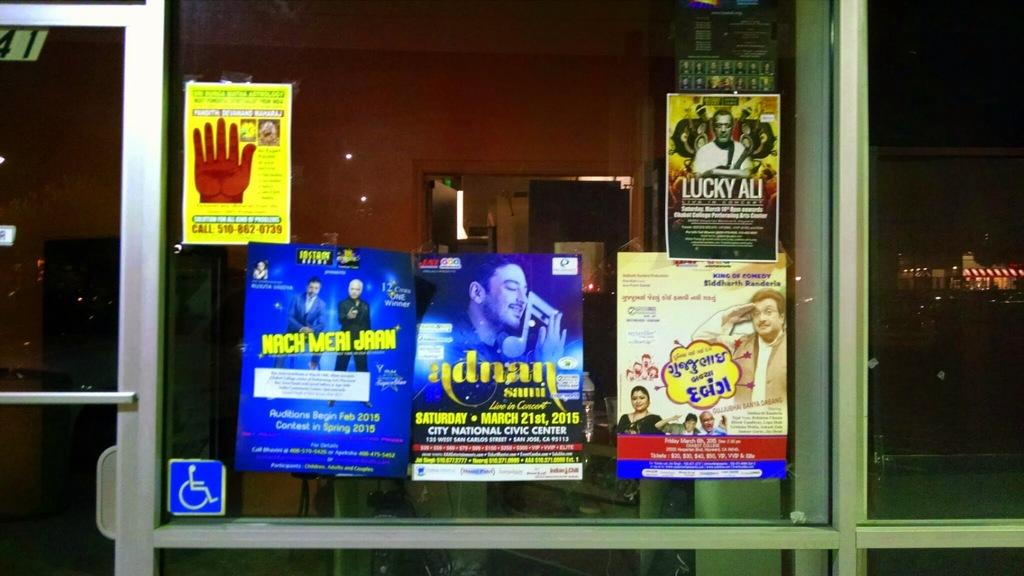<image>
Relay a brief, clear account of the picture shown. A poster for Nach Meri Jaan sits in a window with other posters 